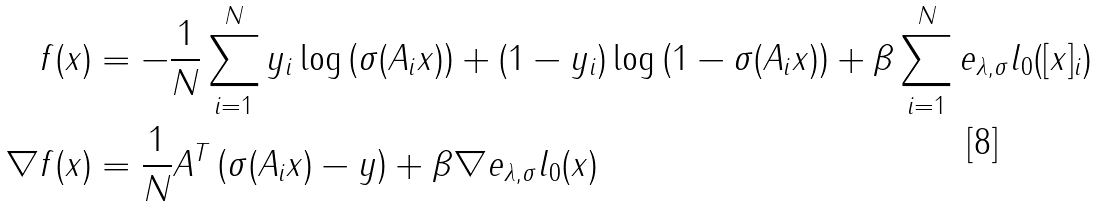<formula> <loc_0><loc_0><loc_500><loc_500>f ( x ) & = - \frac { 1 } { N } \sum _ { i = 1 } ^ { N } y _ { i } \log \left ( \sigma ( A _ { i } x ) \right ) + ( 1 - y _ { i } ) \log \left ( 1 - \sigma ( A _ { i } x ) \right ) + \beta \sum _ { i = 1 } ^ { N } e _ { \lambda , \sigma } l _ { 0 } ( [ x ] _ { i } ) \\ \nabla f ( x ) & = \frac { 1 } { N } A ^ { T } \left ( \sigma ( A _ { i } x ) - y \right ) + \beta \nabla e _ { \lambda , \sigma } l _ { 0 } ( x )</formula> 